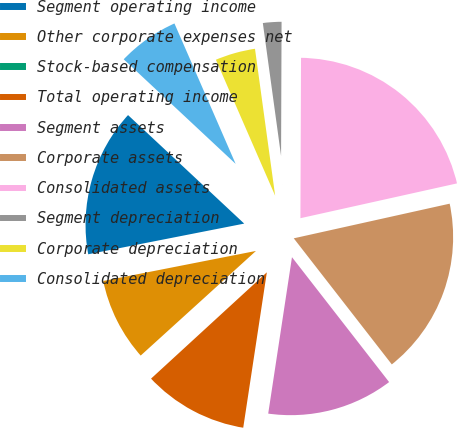Convert chart. <chart><loc_0><loc_0><loc_500><loc_500><pie_chart><fcel>Segment operating income<fcel>Other corporate expenses net<fcel>Stock-based compensation<fcel>Total operating income<fcel>Segment assets<fcel>Corporate assets<fcel>Consolidated assets<fcel>Segment depreciation<fcel>Corporate depreciation<fcel>Consolidated depreciation<nl><fcel>15.05%<fcel>8.64%<fcel>0.09%<fcel>10.78%<fcel>12.92%<fcel>17.96%<fcel>21.46%<fcel>2.23%<fcel>4.37%<fcel>6.5%<nl></chart> 